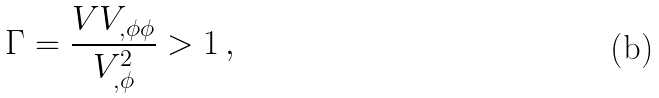<formula> <loc_0><loc_0><loc_500><loc_500>\Gamma = \frac { V V _ { , \phi \phi } } { V _ { , \phi } ^ { 2 } } > 1 \, ,</formula> 